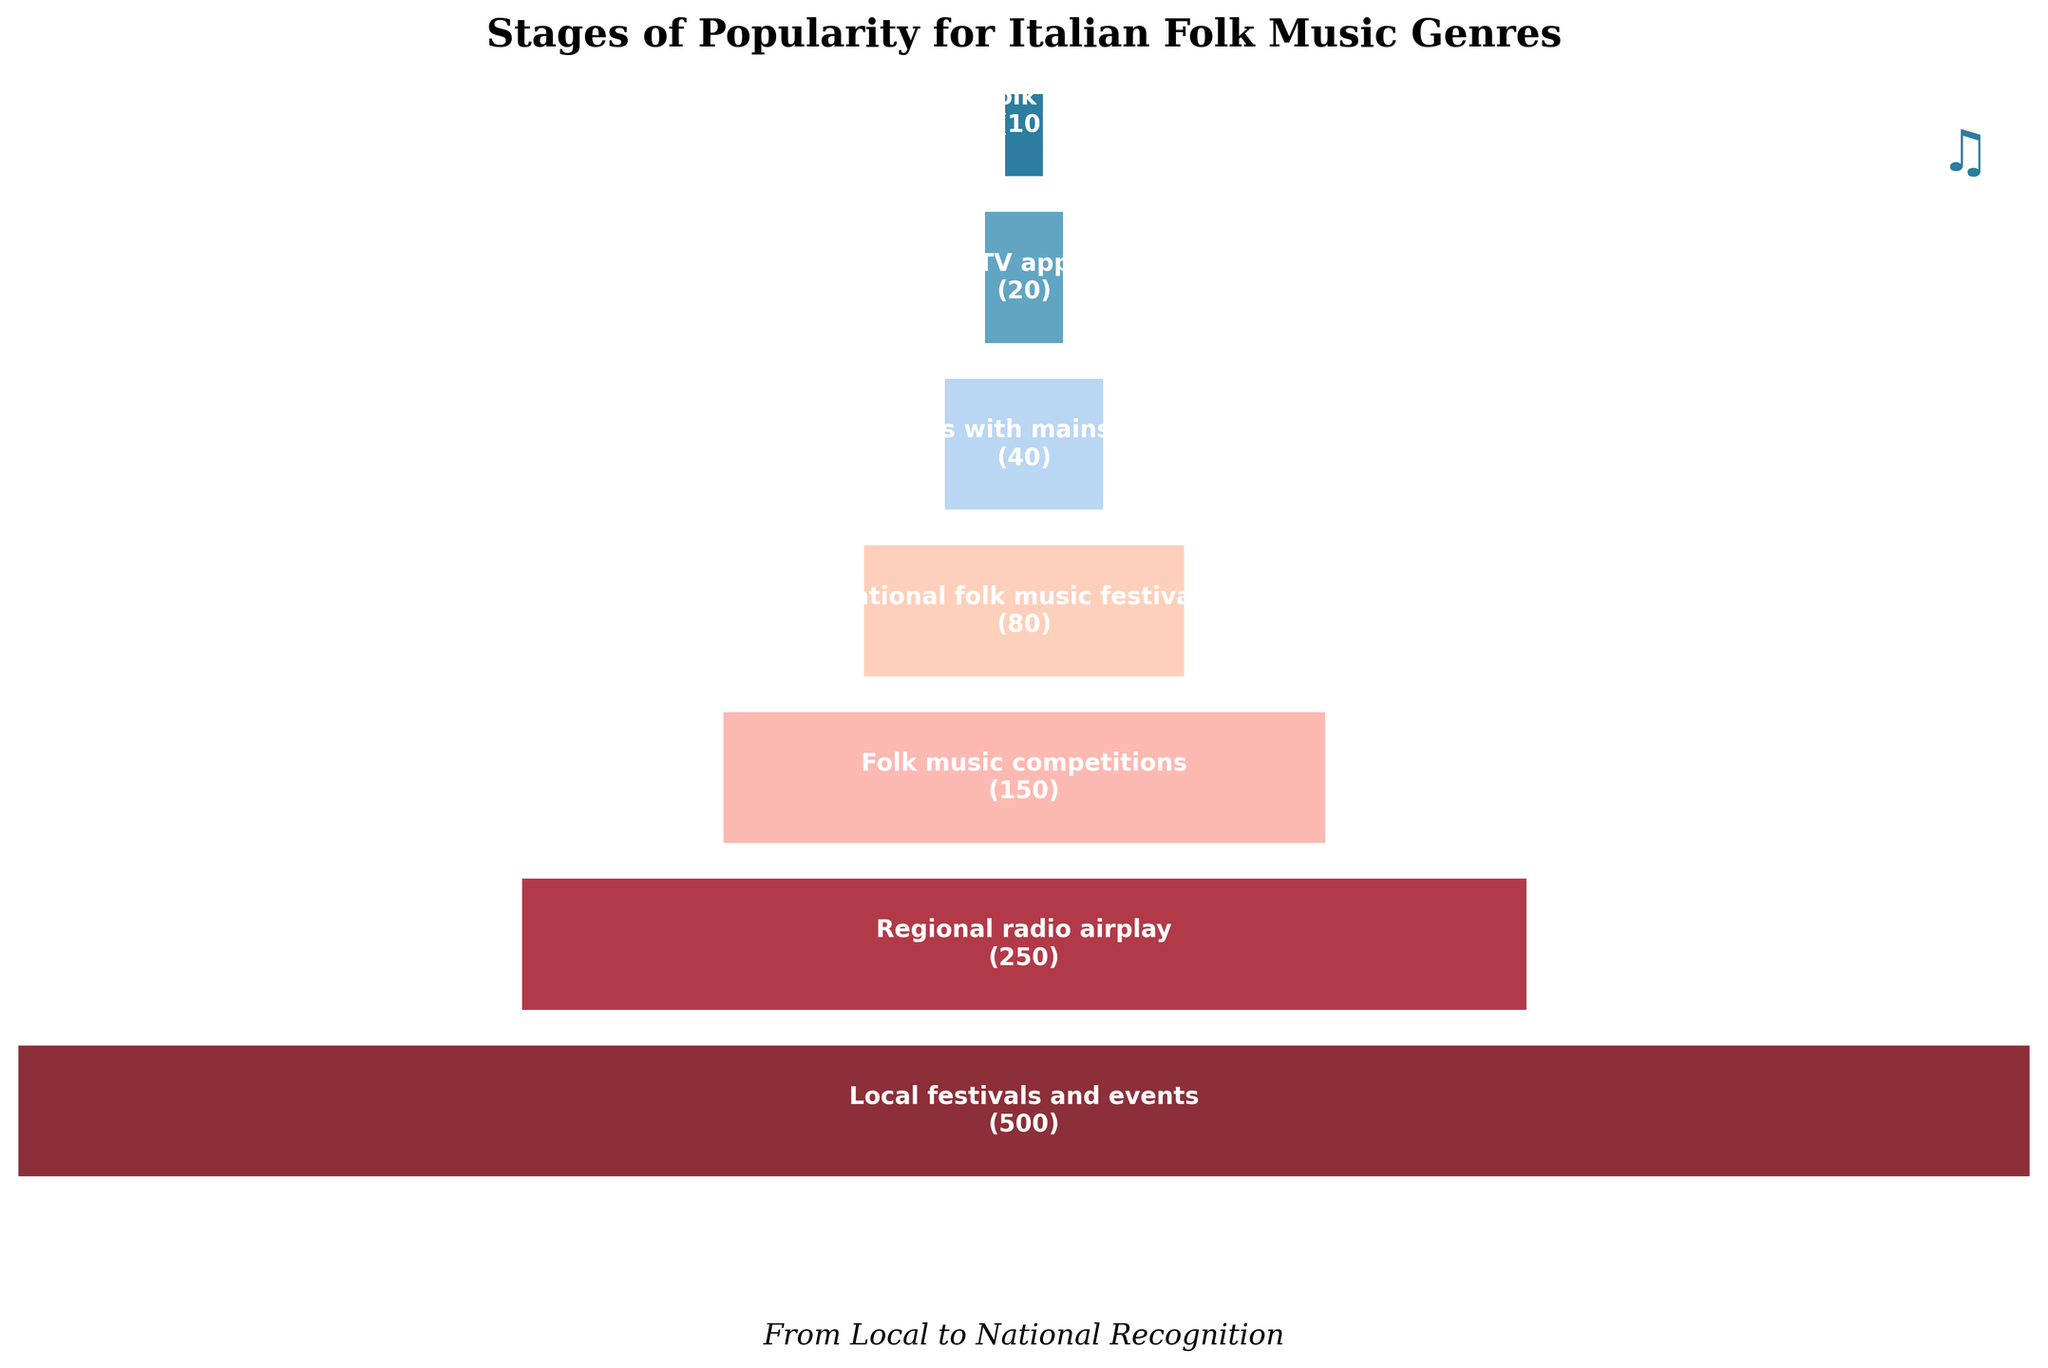What is the title of the funnel chart? The title is usually located at the top of the graph. Here, the title "Stages of Popularity for Italian Folk Music Genres" is written in bold and larger font.
Answer: Stages of Popularity for Italian Folk Music Genres How many stages are represented in the funnel chart? By counting the number of segments in the funnel, we can see there are 7 stages. Each stage represents a different step in the popularity progression.
Answer: 7 Which stage has the maximum number of artists? The largest width segment at the top of the funnel indicates the stage with the highest number of artists, which is "Local festivals and events" with 500 artists.
Answer: Local festivals and events How many artists appear on national TV? By examining the text within each segment of the funnel, we find that "National TV appearances" has 20 artists.
Answer: 20 What is the difference in the number of artists between local festivals and international festivals? To find the difference, subtract the number of artists in "International folk music festivals" (10) from those in "Local festivals and events" (500).
Answer: 490 How many artists participate in folk music competitions? The number is displayed inside the respective segment of the funnel. For "Folk music competitions," it is 150 artists.
Answer: 150 Compare the number of artists participating in national TV appearances to those in regional radio airplay. Which stage has more artists? By looking at the funnel chart, "Regional radio airplay" has 250 artists while "National TV appearances" has 20. Therefore, regional radio airplay has more artists.
Answer: Regional radio airplay What percentage of artists who participate in local festivals also appear in national folk music festivals? First, find the number of artists in both stages: Local festivals (500) and National folk music festivals (80). The percentage is calculated as (80/500) * 100%.
Answer: 16% Which stage sees a quarter of the artists from regional radio airplay? One-fourth of the artists from regional radio airplay (250) is 250/4 = 62.5. The closest number of artists in the stages is "National folk music festivals" with 80 artists.
Answer: National folk music festivals Arrange the stages in ascending order of the number of artists. By looking at the chart from bottom to top: International folk music festivals (10), National TV appearances (20), Collaborations with mainstream artists (40), National folk music festivals (80), Folk music competitions (150), Regional radio airplay (250), Local festivals and events (500).
Answer: International folk music festivals, National TV appearances, Collaborations with mainstream artists, National folk music festivals, Folk music competitions, Regional radio airplay, Local festivals and events 